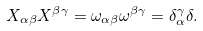Convert formula to latex. <formula><loc_0><loc_0><loc_500><loc_500>X _ { \alpha \beta } X ^ { \beta \gamma } = \omega _ { \alpha \beta } \omega ^ { \beta \gamma } = \delta ^ { \gamma } _ { \alpha } \delta .</formula> 